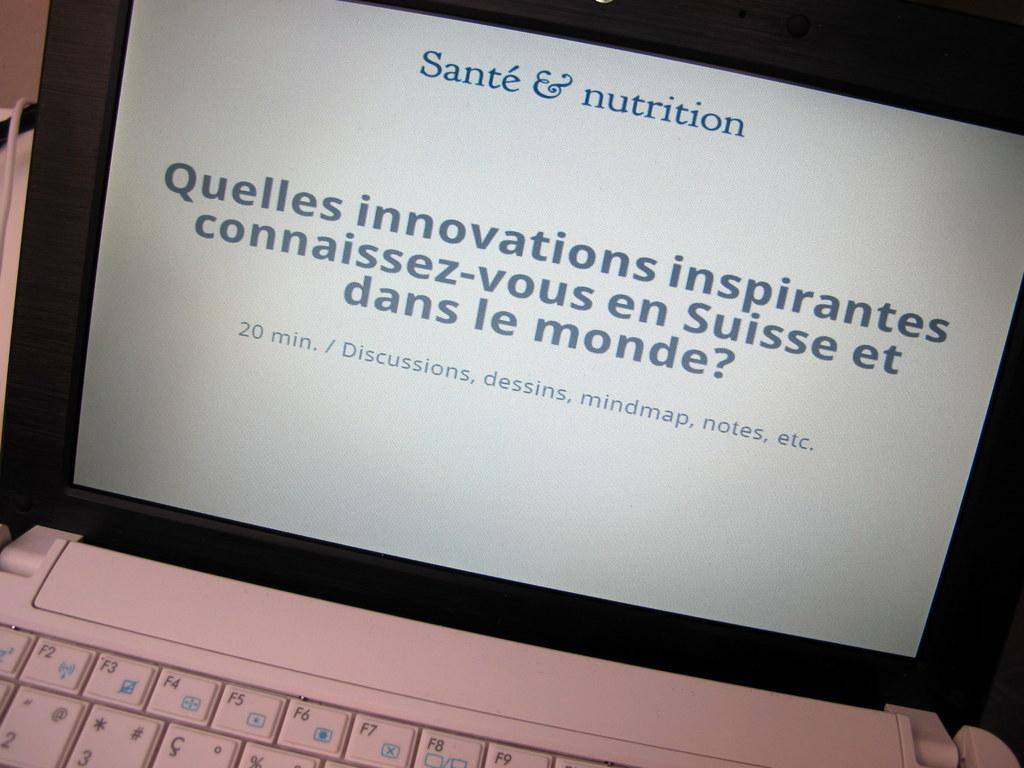Provide a one-sentence caption for the provided image. A slide in French on a computer screen from Sante & nutrition. 